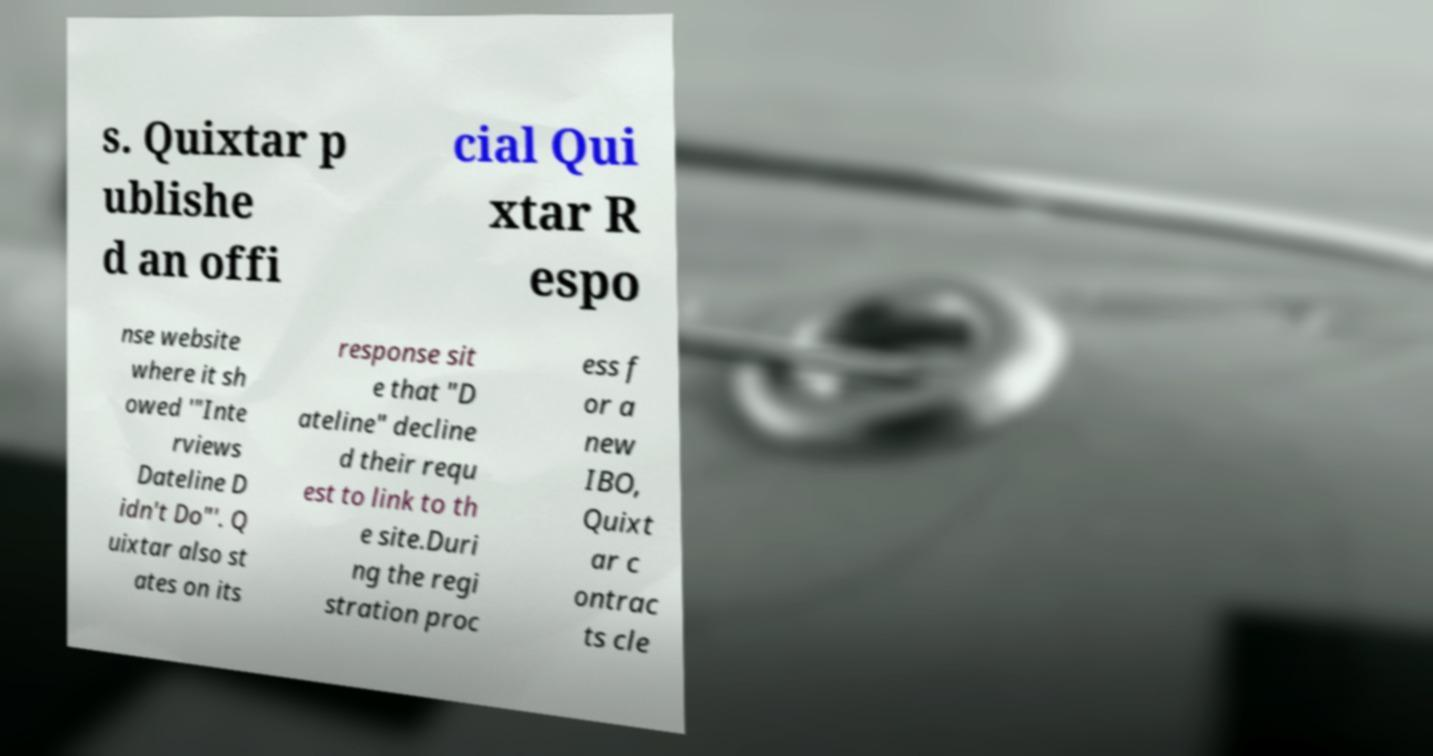I need the written content from this picture converted into text. Can you do that? s. Quixtar p ublishe d an offi cial Qui xtar R espo nse website where it sh owed '"Inte rviews Dateline D idn't Do"'. Q uixtar also st ates on its response sit e that "D ateline" decline d their requ est to link to th e site.Duri ng the regi stration proc ess f or a new IBO, Quixt ar c ontrac ts cle 